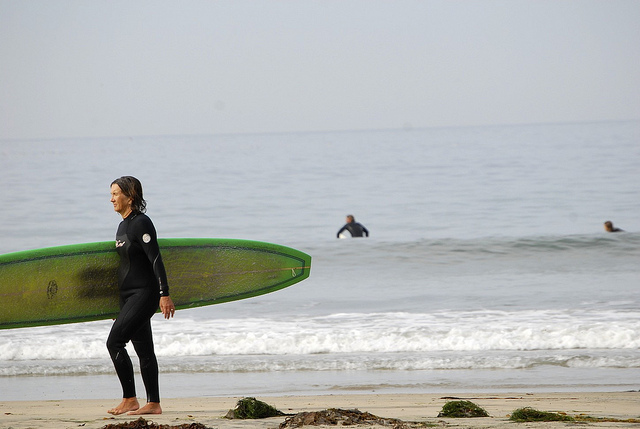Is there any indication of the time of day in the image? The image does not provide any definite indication of the specific time of day. There are no shadows or clear sun positioning visible that would suggest whether it is morning, afternoon, or evening. The sky is relatively clear and bright, but this alone does not offer a direct clue about the exact time. 